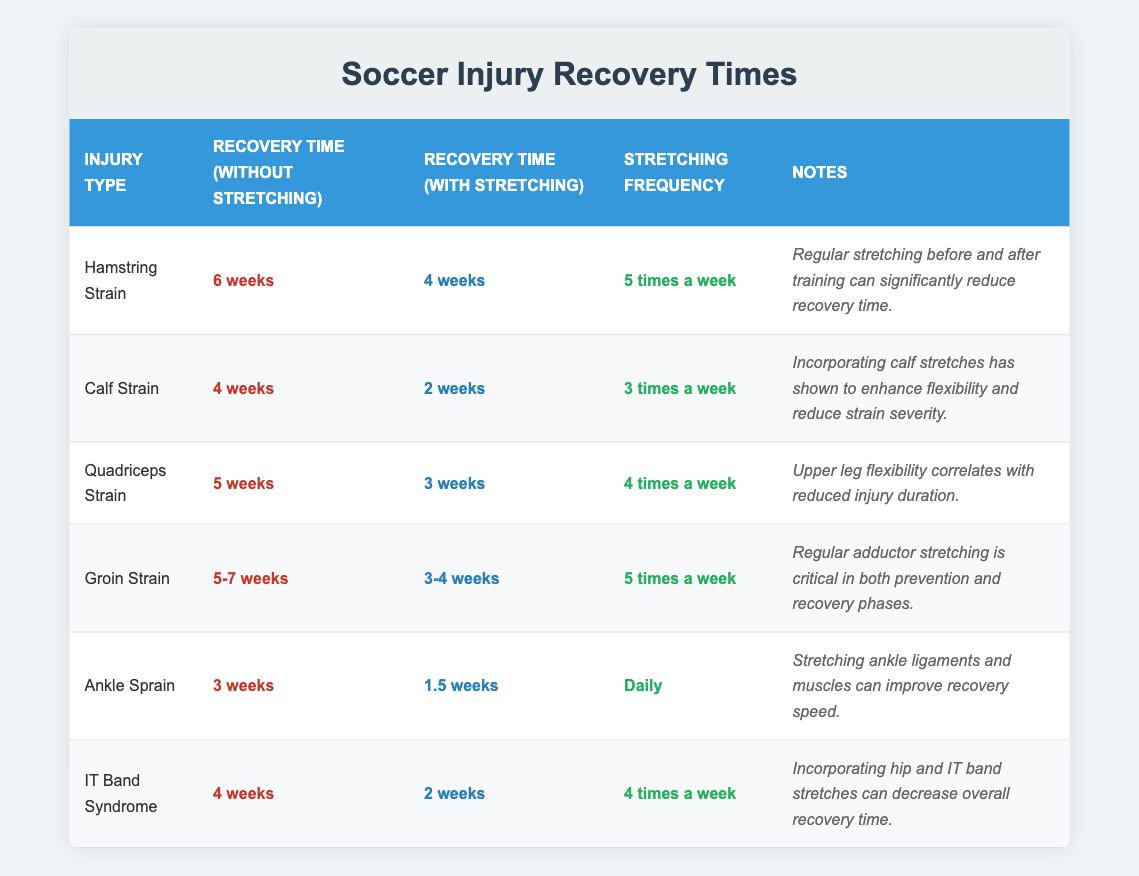What is the recovery time for a hamstring strain without stretching? The table lists the recovery time for a hamstring strain without any stretching as 6 weeks. I can directly refer to the corresponding value in the "Recovery Time (Without Stretching)" column for the "Hamstring Strain" row.
Answer: 6 weeks What is the stretching frequency for calf strain recovery? In the table, the stretching frequency for calf strain recovery is 3 times a week, as noted in the "Stretching Frequency" column for the "Calf Strain" row.
Answer: 3 times a week True or False: The recovery time for an ankle sprain with stretching is shorter than the recovery time without stretching. According to the table, the recovery time for an ankle sprain without stretching is 3 weeks, whereas with stretching it is 1.5 weeks. Since 1.5 weeks is indeed shorter than 3 weeks, the statement is true.
Answer: True What is the average recovery time with stretching for quadriceps strain and groin strain? The recovery time with stretching for a quadriceps strain is 3 weeks, and for groin strain, it ranges from 3 to 4 weeks. To determine the average, we take the lower estimate (3 weeks) for groin strain, add them (3 + 3 = 6 weeks), and divide by 2, resulting in an average of 3 weeks. Therefore, it should be (3 + 3.5) / 2 = 3.25 weeks.
Answer: 3.25 weeks How much time is saved in recovery with stretching for IT band syndrome? The recovery time for IT Band Syndrome without stretching is 4 weeks, and with stretching, it is 2 weeks. The difference in recovery time (4 weeks - 2 weeks) indicates a time savings of 2 weeks.
Answer: 2 weeks What is the range of recovery time for a groin strain with stretching? The table shows the recovery time for a groin strain with stretching as 3-4 weeks. This indicates the minimum recovery time is 3 weeks and the maximum is 4 weeks, thus the range is between these two values.
Answer: 3-4 weeks 